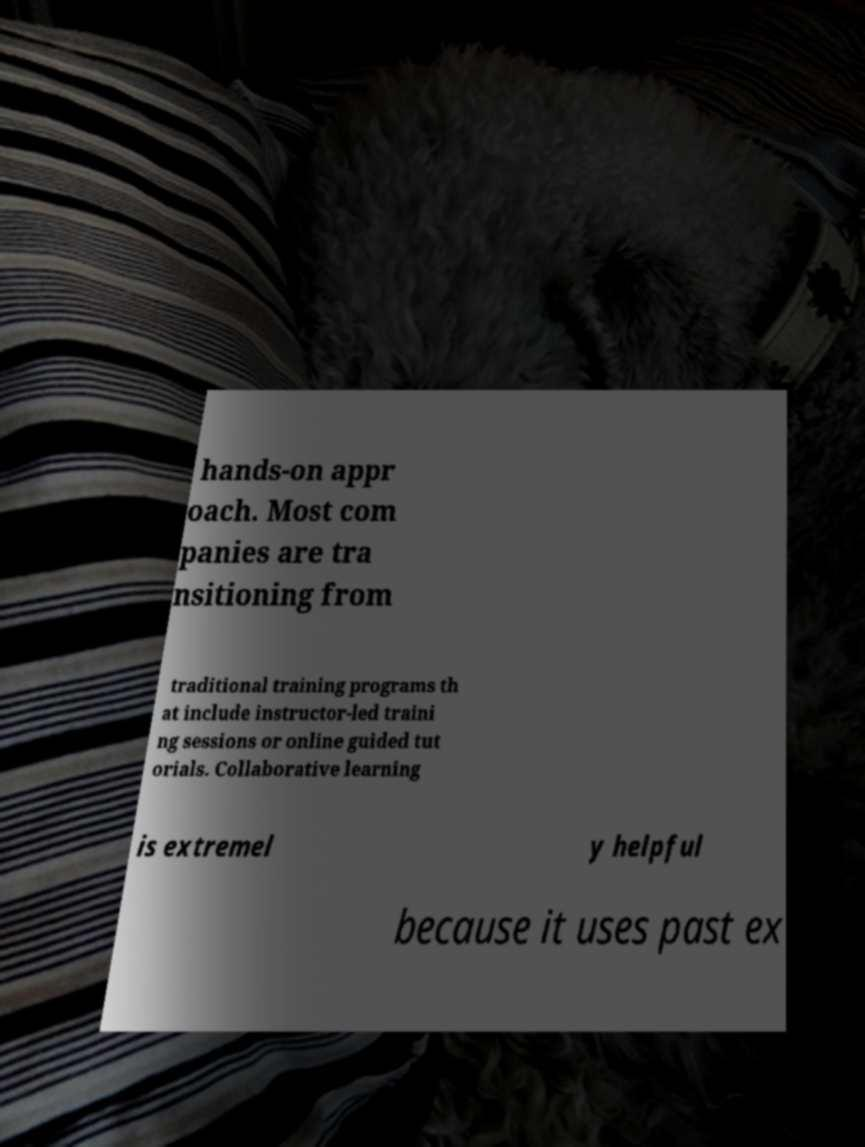Please read and relay the text visible in this image. What does it say? hands-on appr oach. Most com panies are tra nsitioning from traditional training programs th at include instructor-led traini ng sessions or online guided tut orials. Collaborative learning is extremel y helpful because it uses past ex 